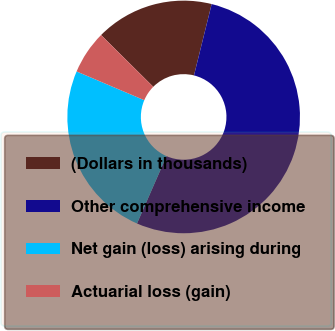Convert chart to OTSL. <chart><loc_0><loc_0><loc_500><loc_500><pie_chart><fcel>(Dollars in thousands)<fcel>Other comprehensive income<fcel>Net gain (loss) arising during<fcel>Actuarial loss (gain)<nl><fcel>16.44%<fcel>52.7%<fcel>24.83%<fcel>6.04%<nl></chart> 